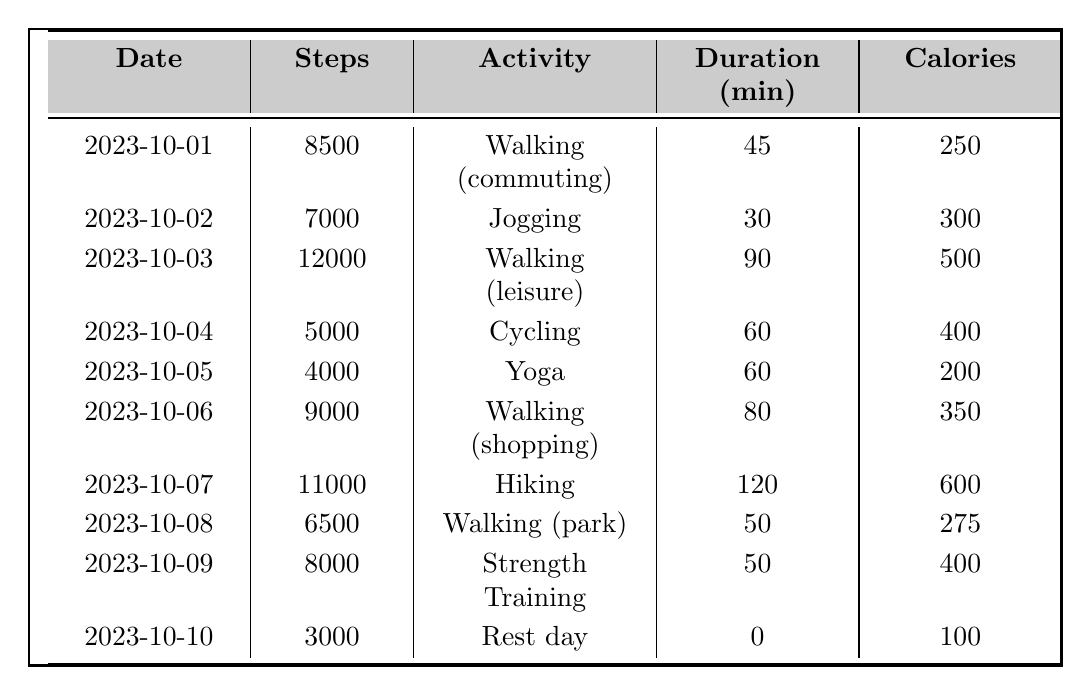What was the highest number of steps taken in a single day? By reviewing the "Steps" column in the table, the maximum recorded steps are 12,000 on 2023-10-03.
Answer: 12,000 What activity corresponds to the most calories burned? The table shows that Hiking on 2023-10-07 burned 600 calories, which is higher than any other activity listed.
Answer: Hiking On how many days did the individual take more than 8,000 steps? Examining the "Steps" column reveals that there are 5 days with steps exceeding 8,000: 10,000 (2023-10-03), 11,000 (2023-10-07), and 9,000 (2023-10-06).
Answer: 5 What is the average duration of activities over the 10 days? To find the average, sum the durations: 45 + 30 + 90 + 60 + 60 + 80 + 120 + 50 + 50 + 0 = 525 minutes, then divide by 10 days: 525/10 = 52.5 minutes.
Answer: 52.5 minutes Did the individual have a rest day? The entry for 2023-10-10 indicates a "Rest day," confirming that there was indeed a rest day in the log.
Answer: Yes What was the total number of calories burned across all activities? Adding the calories burned: 250 + 300 + 500 + 400 + 200 + 350 + 600 + 275 + 400 + 100 = 3075 calories.
Answer: 3,075 calories What activity was performed on the day with the least number of steps? The day with the fewest steps, 2023-10-10 with 3,000 steps, corresponds to "Rest day."
Answer: Rest day How many activities listed involve walking? There are four instances where walking is the main activity: Walking (commuting), Walking (leisure), Walking (shopping), and Walking (park).
Answer: 4 Was there a day when the calorie burn was exactly 200? Reviewing the table, 2023-10-05 shows an entry for Yoga, which burned exactly 200 calories.
Answer: Yes Calculate the difference in calories burned between the highest and lowest activity days. The highest calories burned was 600 (Hiking), and the lowest was 100 (Rest day). The difference is 600 - 100 = 500 calories.
Answer: 500 calories 